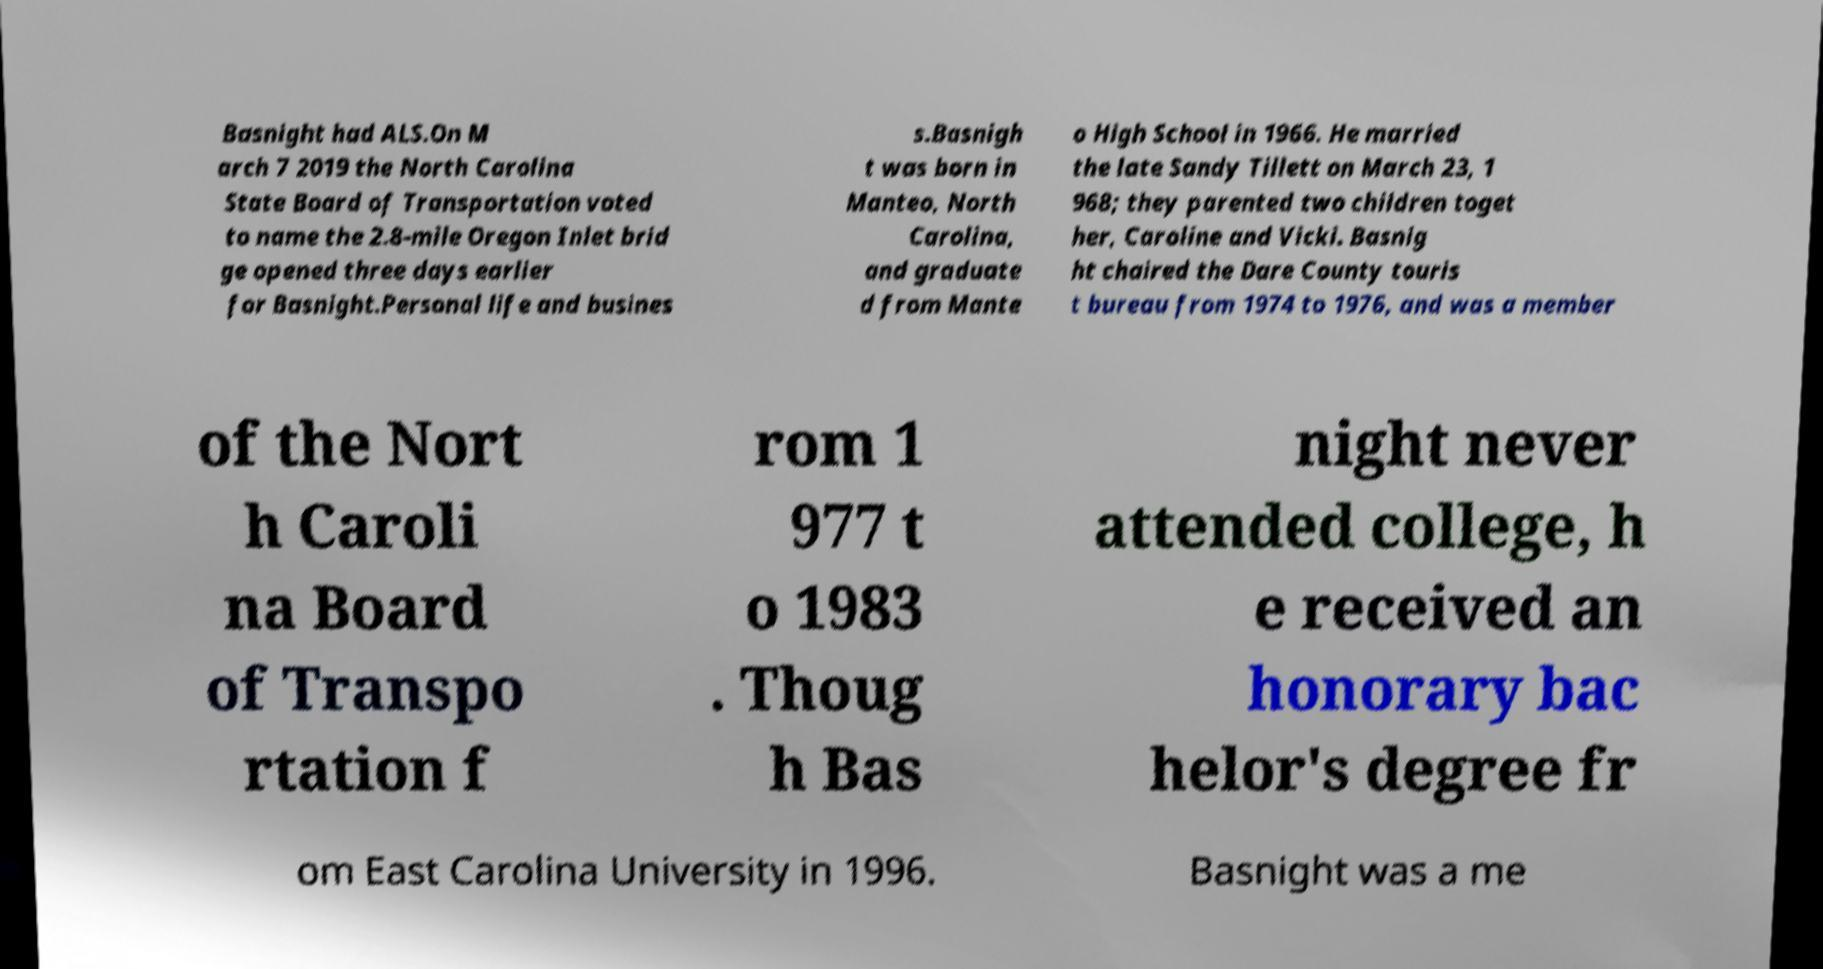For documentation purposes, I need the text within this image transcribed. Could you provide that? Basnight had ALS.On M arch 7 2019 the North Carolina State Board of Transportation voted to name the 2.8-mile Oregon Inlet brid ge opened three days earlier for Basnight.Personal life and busines s.Basnigh t was born in Manteo, North Carolina, and graduate d from Mante o High School in 1966. He married the late Sandy Tillett on March 23, 1 968; they parented two children toget her, Caroline and Vicki. Basnig ht chaired the Dare County touris t bureau from 1974 to 1976, and was a member of the Nort h Caroli na Board of Transpo rtation f rom 1 977 t o 1983 . Thoug h Bas night never attended college, h e received an honorary bac helor's degree fr om East Carolina University in 1996. Basnight was a me 